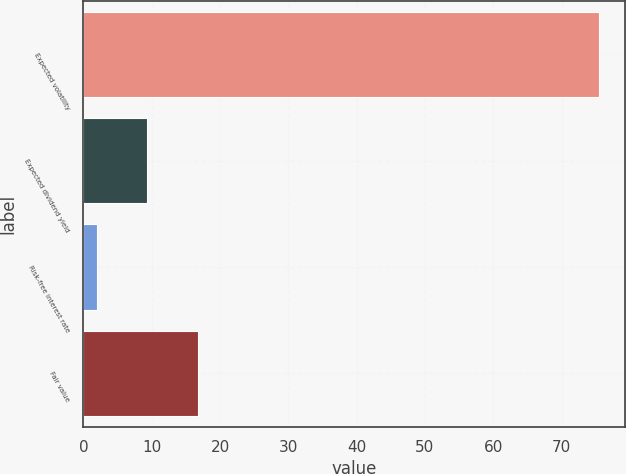Convert chart. <chart><loc_0><loc_0><loc_500><loc_500><bar_chart><fcel>Expected volatility<fcel>Expected dividend yield<fcel>Risk-free interest rate<fcel>Fair value<nl><fcel>75.5<fcel>9.35<fcel>2<fcel>16.7<nl></chart> 